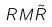<formula> <loc_0><loc_0><loc_500><loc_500>R M \tilde { R }</formula> 